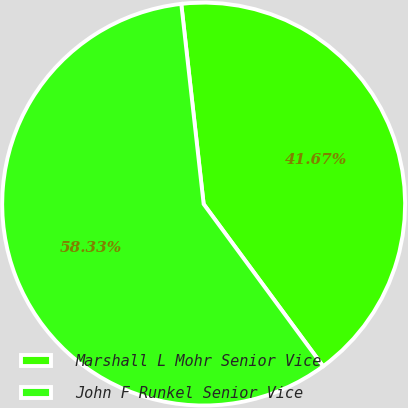<chart> <loc_0><loc_0><loc_500><loc_500><pie_chart><fcel>Marshall L Mohr Senior Vice<fcel>John F Runkel Senior Vice<nl><fcel>41.67%<fcel>58.33%<nl></chart> 